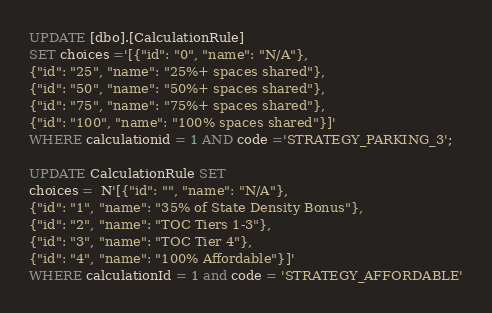Convert code to text. <code><loc_0><loc_0><loc_500><loc_500><_SQL_>UPDATE [dbo].[CalculationRule]
SET choices ='[{"id": "0", "name": "N/A"},
{"id": "25", "name": "25%+ spaces shared"},
{"id": "50", "name": "50%+ spaces shared"},
{"id": "75", "name": "75%+ spaces shared"},
{"id": "100", "name": "100% spaces shared"}]'
WHERE calculationid = 1 AND code ='STRATEGY_PARKING_3';

UPDATE CalculationRule SET
choices =  N'[{"id": "", "name": "N/A"},
{"id": "1", "name": "35% of State Density Bonus"},
{"id": "2", "name": "TOC Tiers 1-3"},
{"id": "3", "name": "TOC Tier 4"},
{"id": "4", "name": "100% Affordable"}]'
WHERE calculationId = 1 and code = 'STRATEGY_AFFORDABLE'</code> 